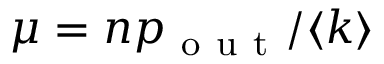Convert formula to latex. <formula><loc_0><loc_0><loc_500><loc_500>\mu = n p _ { o u t } / \langle k \rangle</formula> 